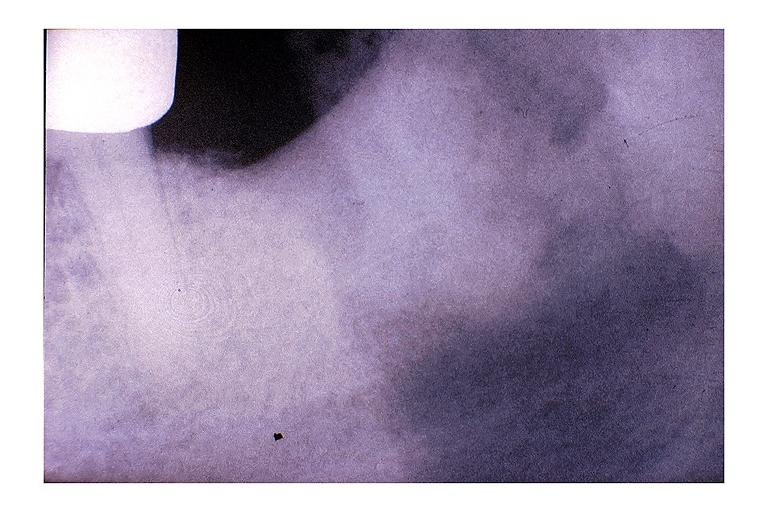s oral present?
Answer the question using a single word or phrase. Yes 